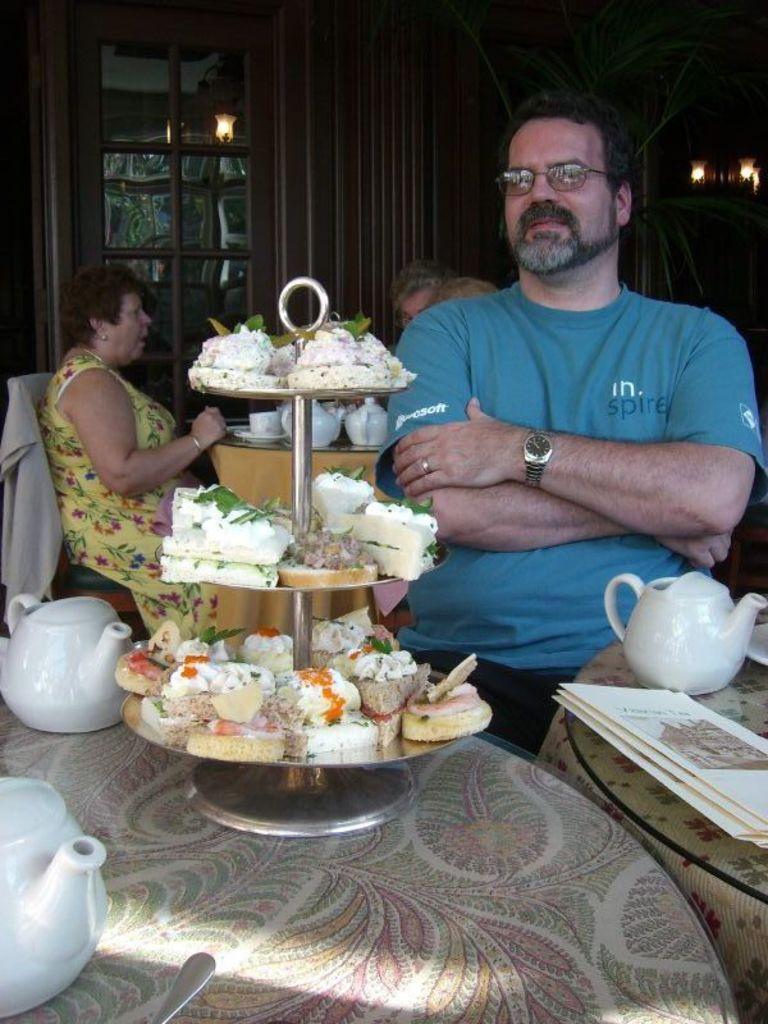In one or two sentences, can you explain what this image depicts? The image is taken in the restaurant. There are people sitting around the tables. At the bottom of the image there are tables. We can see teapots and some foods placed on the tables. In the background there is a door. 